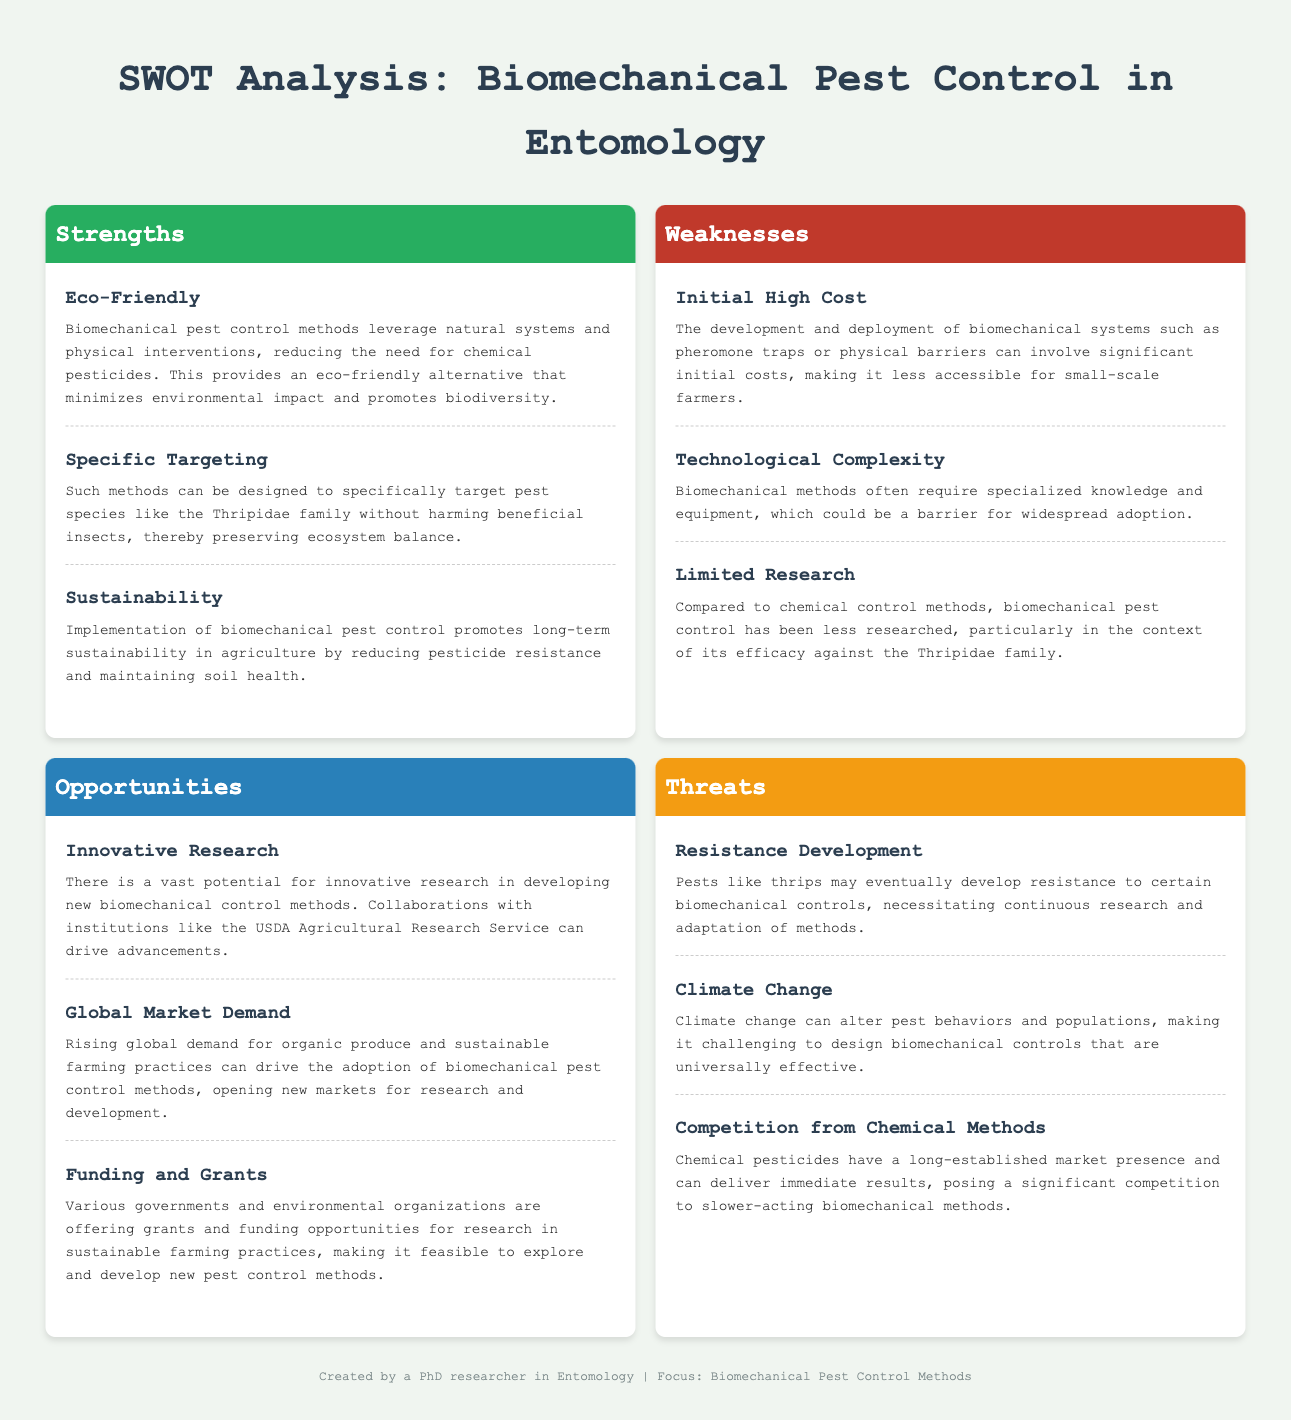What is the title of the document? The title is presented in the header of the document.
Answer: SWOT Analysis: Biomechanical Pest Control in Entomology What are the strengths listed in the SWOT analysis? The strengths are outlined in their respective section and include specific factors.
Answer: Eco-Friendly, Specific Targeting, Sustainability What is one weakness related to the cost of biomechanical methods? The document mentions initial costs as a significant concern.
Answer: Initial High Cost Which research opportunity is mentioned in the document? Opportunities are discussed, highlighting potential areas for advancement in pest control methods.
Answer: Innovative Research What is one potential threat to biomechanical pest control methods? The threats section identifies various risks that could impact the effectiveness of these methods.
Answer: Resistance Development What type of information is the "Specific Targeting" strength referring to? This strength relates to the capability of biomechanical methods to focus on pests without affecting beneficial insects.
Answer: Pest species targeting What is a challenge related to technology in biomechanical methods? The document addresses barriers to adoption, focusing on the technical aspects required for implementation.
Answer: Technological Complexity Who can drive advancements in biomechanical pest control? The document mentions possible collaborators for research developments in this area.
Answer: USDA Agricultural Research Service What does the strength "Sustainability" refer to in the context of pest control? This strength is about the long-term benefits of reducing pesticide dependence and maintaining ecosystem health.
Answer: Long-term sustainability in agriculture 